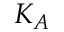<formula> <loc_0><loc_0><loc_500><loc_500>K _ { A }</formula> 